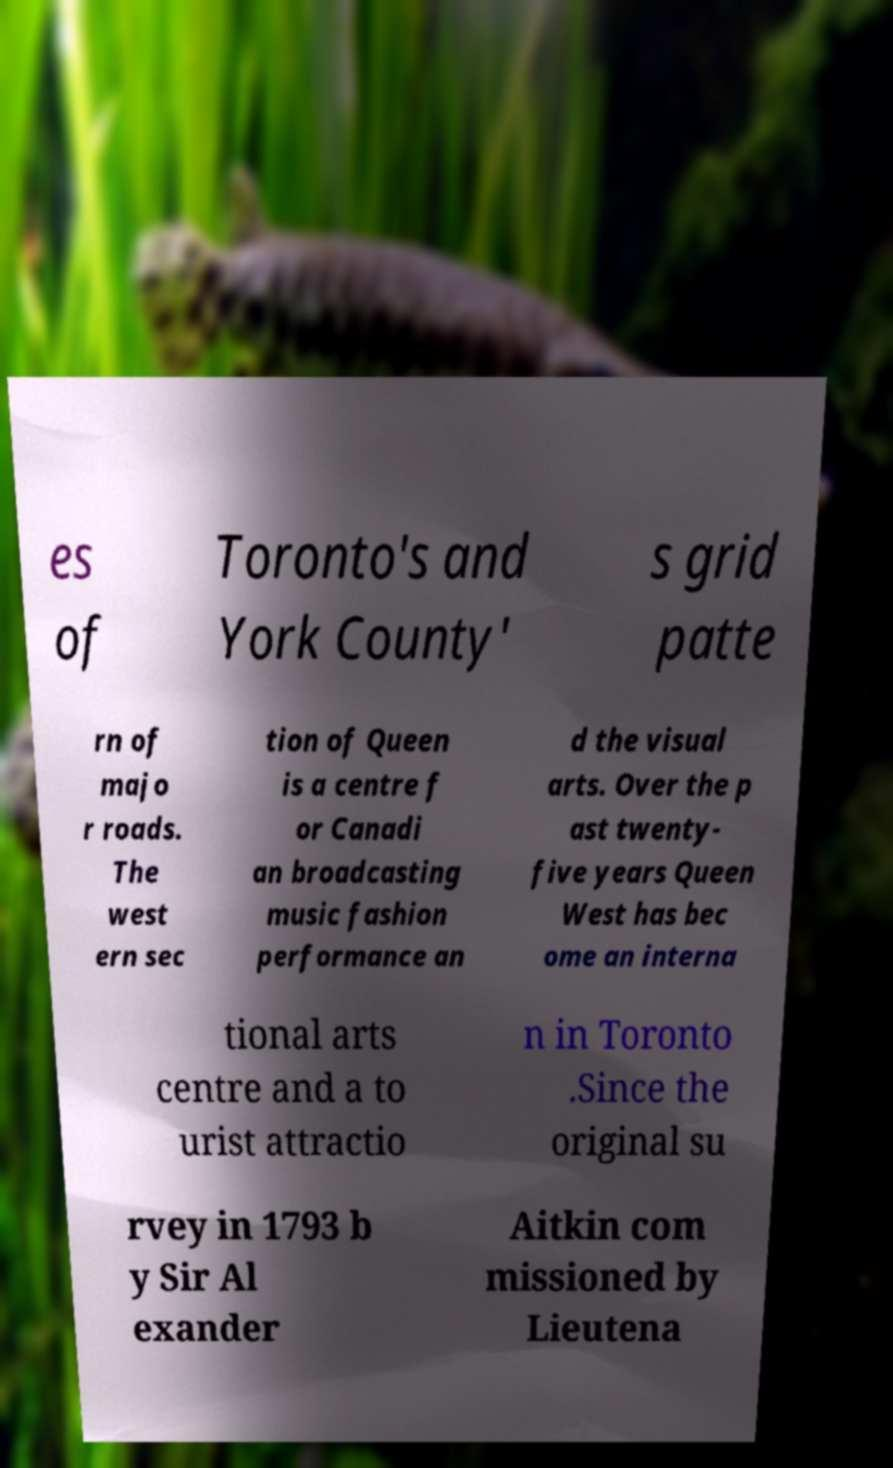Please read and relay the text visible in this image. What does it say? es of Toronto's and York County' s grid patte rn of majo r roads. The west ern sec tion of Queen is a centre f or Canadi an broadcasting music fashion performance an d the visual arts. Over the p ast twenty- five years Queen West has bec ome an interna tional arts centre and a to urist attractio n in Toronto .Since the original su rvey in 1793 b y Sir Al exander Aitkin com missioned by Lieutena 